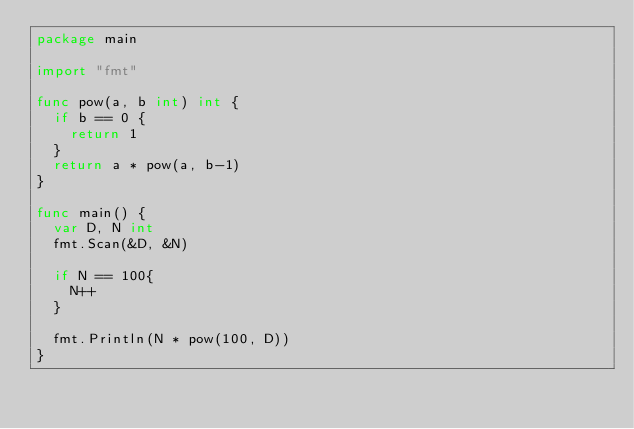<code> <loc_0><loc_0><loc_500><loc_500><_Go_>package main

import "fmt"

func pow(a, b int) int {
	if b == 0 {
		return 1
	}
	return a * pow(a, b-1)
}

func main() {
	var D, N int
	fmt.Scan(&D, &N)
	
	if N == 100{
		N++
	}

	fmt.Println(N * pow(100, D))
}
</code> 